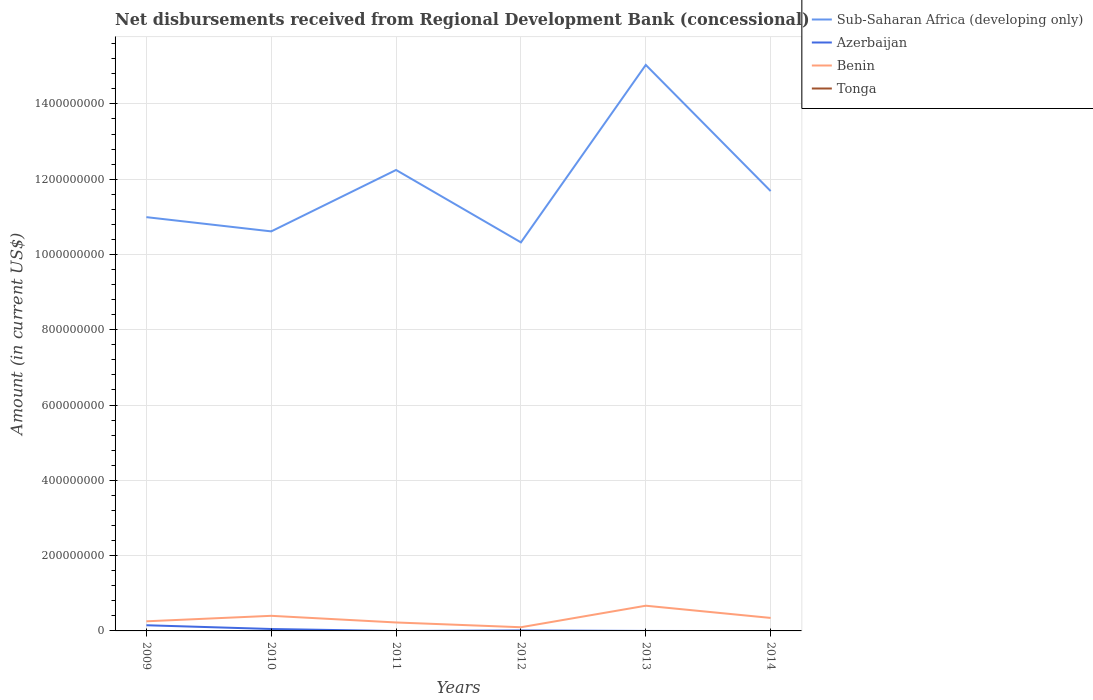Is the number of lines equal to the number of legend labels?
Ensure brevity in your answer.  No. Across all years, what is the maximum amount of disbursements received from Regional Development Bank in Benin?
Your response must be concise. 9.79e+06. What is the total amount of disbursements received from Regional Development Bank in Azerbaijan in the graph?
Keep it short and to the point. 9.99e+06. What is the difference between the highest and the second highest amount of disbursements received from Regional Development Bank in Azerbaijan?
Your response must be concise. 1.51e+07. What is the difference between the highest and the lowest amount of disbursements received from Regional Development Bank in Azerbaijan?
Ensure brevity in your answer.  2. Is the amount of disbursements received from Regional Development Bank in Benin strictly greater than the amount of disbursements received from Regional Development Bank in Tonga over the years?
Ensure brevity in your answer.  No. How many lines are there?
Your answer should be very brief. 3. Are the values on the major ticks of Y-axis written in scientific E-notation?
Give a very brief answer. No. Does the graph contain any zero values?
Your answer should be very brief. Yes. Does the graph contain grids?
Your answer should be compact. Yes. What is the title of the graph?
Offer a very short reply. Net disbursements received from Regional Development Bank (concessional). Does "Madagascar" appear as one of the legend labels in the graph?
Make the answer very short. No. What is the label or title of the X-axis?
Make the answer very short. Years. What is the Amount (in current US$) in Sub-Saharan Africa (developing only) in 2009?
Offer a terse response. 1.10e+09. What is the Amount (in current US$) in Azerbaijan in 2009?
Your response must be concise. 1.51e+07. What is the Amount (in current US$) of Benin in 2009?
Ensure brevity in your answer.  2.55e+07. What is the Amount (in current US$) in Sub-Saharan Africa (developing only) in 2010?
Your response must be concise. 1.06e+09. What is the Amount (in current US$) in Azerbaijan in 2010?
Provide a succinct answer. 5.08e+06. What is the Amount (in current US$) in Benin in 2010?
Your answer should be compact. 4.01e+07. What is the Amount (in current US$) of Sub-Saharan Africa (developing only) in 2011?
Your answer should be very brief. 1.22e+09. What is the Amount (in current US$) in Azerbaijan in 2011?
Offer a terse response. 0. What is the Amount (in current US$) of Benin in 2011?
Make the answer very short. 2.25e+07. What is the Amount (in current US$) of Tonga in 2011?
Provide a succinct answer. 0. What is the Amount (in current US$) in Sub-Saharan Africa (developing only) in 2012?
Keep it short and to the point. 1.03e+09. What is the Amount (in current US$) of Azerbaijan in 2012?
Your answer should be very brief. 1.30e+06. What is the Amount (in current US$) in Benin in 2012?
Ensure brevity in your answer.  9.79e+06. What is the Amount (in current US$) in Sub-Saharan Africa (developing only) in 2013?
Ensure brevity in your answer.  1.50e+09. What is the Amount (in current US$) of Azerbaijan in 2013?
Give a very brief answer. 0. What is the Amount (in current US$) of Benin in 2013?
Offer a very short reply. 6.69e+07. What is the Amount (in current US$) of Sub-Saharan Africa (developing only) in 2014?
Give a very brief answer. 1.17e+09. What is the Amount (in current US$) in Benin in 2014?
Ensure brevity in your answer.  3.45e+07. Across all years, what is the maximum Amount (in current US$) of Sub-Saharan Africa (developing only)?
Offer a terse response. 1.50e+09. Across all years, what is the maximum Amount (in current US$) of Azerbaijan?
Your answer should be very brief. 1.51e+07. Across all years, what is the maximum Amount (in current US$) in Benin?
Keep it short and to the point. 6.69e+07. Across all years, what is the minimum Amount (in current US$) in Sub-Saharan Africa (developing only)?
Provide a short and direct response. 1.03e+09. Across all years, what is the minimum Amount (in current US$) in Azerbaijan?
Your answer should be very brief. 0. Across all years, what is the minimum Amount (in current US$) in Benin?
Provide a succinct answer. 9.79e+06. What is the total Amount (in current US$) in Sub-Saharan Africa (developing only) in the graph?
Offer a terse response. 7.09e+09. What is the total Amount (in current US$) of Azerbaijan in the graph?
Provide a succinct answer. 2.15e+07. What is the total Amount (in current US$) in Benin in the graph?
Provide a succinct answer. 1.99e+08. What is the difference between the Amount (in current US$) in Sub-Saharan Africa (developing only) in 2009 and that in 2010?
Make the answer very short. 3.78e+07. What is the difference between the Amount (in current US$) of Azerbaijan in 2009 and that in 2010?
Offer a very short reply. 9.99e+06. What is the difference between the Amount (in current US$) of Benin in 2009 and that in 2010?
Offer a terse response. -1.46e+07. What is the difference between the Amount (in current US$) in Sub-Saharan Africa (developing only) in 2009 and that in 2011?
Provide a short and direct response. -1.25e+08. What is the difference between the Amount (in current US$) in Benin in 2009 and that in 2011?
Make the answer very short. 3.10e+06. What is the difference between the Amount (in current US$) in Sub-Saharan Africa (developing only) in 2009 and that in 2012?
Offer a very short reply. 6.70e+07. What is the difference between the Amount (in current US$) of Azerbaijan in 2009 and that in 2012?
Give a very brief answer. 1.38e+07. What is the difference between the Amount (in current US$) in Benin in 2009 and that in 2012?
Ensure brevity in your answer.  1.58e+07. What is the difference between the Amount (in current US$) of Sub-Saharan Africa (developing only) in 2009 and that in 2013?
Make the answer very short. -4.04e+08. What is the difference between the Amount (in current US$) in Benin in 2009 and that in 2013?
Provide a succinct answer. -4.14e+07. What is the difference between the Amount (in current US$) in Sub-Saharan Africa (developing only) in 2009 and that in 2014?
Offer a very short reply. -6.93e+07. What is the difference between the Amount (in current US$) in Benin in 2009 and that in 2014?
Offer a very short reply. -8.99e+06. What is the difference between the Amount (in current US$) in Sub-Saharan Africa (developing only) in 2010 and that in 2011?
Ensure brevity in your answer.  -1.63e+08. What is the difference between the Amount (in current US$) of Benin in 2010 and that in 2011?
Ensure brevity in your answer.  1.77e+07. What is the difference between the Amount (in current US$) in Sub-Saharan Africa (developing only) in 2010 and that in 2012?
Provide a short and direct response. 2.92e+07. What is the difference between the Amount (in current US$) in Azerbaijan in 2010 and that in 2012?
Your answer should be compact. 3.79e+06. What is the difference between the Amount (in current US$) of Benin in 2010 and that in 2012?
Provide a succinct answer. 3.03e+07. What is the difference between the Amount (in current US$) in Sub-Saharan Africa (developing only) in 2010 and that in 2013?
Ensure brevity in your answer.  -4.42e+08. What is the difference between the Amount (in current US$) of Benin in 2010 and that in 2013?
Give a very brief answer. -2.68e+07. What is the difference between the Amount (in current US$) of Sub-Saharan Africa (developing only) in 2010 and that in 2014?
Provide a short and direct response. -1.07e+08. What is the difference between the Amount (in current US$) of Benin in 2010 and that in 2014?
Your response must be concise. 5.58e+06. What is the difference between the Amount (in current US$) in Sub-Saharan Africa (developing only) in 2011 and that in 2012?
Provide a succinct answer. 1.92e+08. What is the difference between the Amount (in current US$) of Benin in 2011 and that in 2012?
Provide a short and direct response. 1.27e+07. What is the difference between the Amount (in current US$) of Sub-Saharan Africa (developing only) in 2011 and that in 2013?
Your response must be concise. -2.79e+08. What is the difference between the Amount (in current US$) of Benin in 2011 and that in 2013?
Ensure brevity in your answer.  -4.45e+07. What is the difference between the Amount (in current US$) in Sub-Saharan Africa (developing only) in 2011 and that in 2014?
Ensure brevity in your answer.  5.60e+07. What is the difference between the Amount (in current US$) in Benin in 2011 and that in 2014?
Offer a very short reply. -1.21e+07. What is the difference between the Amount (in current US$) of Sub-Saharan Africa (developing only) in 2012 and that in 2013?
Your answer should be compact. -4.71e+08. What is the difference between the Amount (in current US$) of Benin in 2012 and that in 2013?
Ensure brevity in your answer.  -5.72e+07. What is the difference between the Amount (in current US$) in Sub-Saharan Africa (developing only) in 2012 and that in 2014?
Offer a terse response. -1.36e+08. What is the difference between the Amount (in current US$) in Benin in 2012 and that in 2014?
Keep it short and to the point. -2.47e+07. What is the difference between the Amount (in current US$) in Sub-Saharan Africa (developing only) in 2013 and that in 2014?
Provide a short and direct response. 3.35e+08. What is the difference between the Amount (in current US$) in Benin in 2013 and that in 2014?
Your answer should be very brief. 3.24e+07. What is the difference between the Amount (in current US$) of Sub-Saharan Africa (developing only) in 2009 and the Amount (in current US$) of Azerbaijan in 2010?
Ensure brevity in your answer.  1.09e+09. What is the difference between the Amount (in current US$) of Sub-Saharan Africa (developing only) in 2009 and the Amount (in current US$) of Benin in 2010?
Keep it short and to the point. 1.06e+09. What is the difference between the Amount (in current US$) in Azerbaijan in 2009 and the Amount (in current US$) in Benin in 2010?
Your response must be concise. -2.50e+07. What is the difference between the Amount (in current US$) of Sub-Saharan Africa (developing only) in 2009 and the Amount (in current US$) of Benin in 2011?
Make the answer very short. 1.08e+09. What is the difference between the Amount (in current US$) of Azerbaijan in 2009 and the Amount (in current US$) of Benin in 2011?
Offer a very short reply. -7.38e+06. What is the difference between the Amount (in current US$) of Sub-Saharan Africa (developing only) in 2009 and the Amount (in current US$) of Azerbaijan in 2012?
Keep it short and to the point. 1.10e+09. What is the difference between the Amount (in current US$) in Sub-Saharan Africa (developing only) in 2009 and the Amount (in current US$) in Benin in 2012?
Your answer should be very brief. 1.09e+09. What is the difference between the Amount (in current US$) of Azerbaijan in 2009 and the Amount (in current US$) of Benin in 2012?
Provide a succinct answer. 5.28e+06. What is the difference between the Amount (in current US$) of Sub-Saharan Africa (developing only) in 2009 and the Amount (in current US$) of Benin in 2013?
Your response must be concise. 1.03e+09. What is the difference between the Amount (in current US$) of Azerbaijan in 2009 and the Amount (in current US$) of Benin in 2013?
Offer a terse response. -5.19e+07. What is the difference between the Amount (in current US$) of Sub-Saharan Africa (developing only) in 2009 and the Amount (in current US$) of Benin in 2014?
Keep it short and to the point. 1.06e+09. What is the difference between the Amount (in current US$) of Azerbaijan in 2009 and the Amount (in current US$) of Benin in 2014?
Keep it short and to the point. -1.95e+07. What is the difference between the Amount (in current US$) of Sub-Saharan Africa (developing only) in 2010 and the Amount (in current US$) of Benin in 2011?
Make the answer very short. 1.04e+09. What is the difference between the Amount (in current US$) of Azerbaijan in 2010 and the Amount (in current US$) of Benin in 2011?
Provide a short and direct response. -1.74e+07. What is the difference between the Amount (in current US$) in Sub-Saharan Africa (developing only) in 2010 and the Amount (in current US$) in Azerbaijan in 2012?
Your answer should be very brief. 1.06e+09. What is the difference between the Amount (in current US$) in Sub-Saharan Africa (developing only) in 2010 and the Amount (in current US$) in Benin in 2012?
Make the answer very short. 1.05e+09. What is the difference between the Amount (in current US$) of Azerbaijan in 2010 and the Amount (in current US$) of Benin in 2012?
Offer a very short reply. -4.71e+06. What is the difference between the Amount (in current US$) in Sub-Saharan Africa (developing only) in 2010 and the Amount (in current US$) in Benin in 2013?
Give a very brief answer. 9.94e+08. What is the difference between the Amount (in current US$) in Azerbaijan in 2010 and the Amount (in current US$) in Benin in 2013?
Provide a succinct answer. -6.19e+07. What is the difference between the Amount (in current US$) of Sub-Saharan Africa (developing only) in 2010 and the Amount (in current US$) of Benin in 2014?
Keep it short and to the point. 1.03e+09. What is the difference between the Amount (in current US$) of Azerbaijan in 2010 and the Amount (in current US$) of Benin in 2014?
Offer a very short reply. -2.95e+07. What is the difference between the Amount (in current US$) in Sub-Saharan Africa (developing only) in 2011 and the Amount (in current US$) in Azerbaijan in 2012?
Make the answer very short. 1.22e+09. What is the difference between the Amount (in current US$) of Sub-Saharan Africa (developing only) in 2011 and the Amount (in current US$) of Benin in 2012?
Make the answer very short. 1.21e+09. What is the difference between the Amount (in current US$) in Sub-Saharan Africa (developing only) in 2011 and the Amount (in current US$) in Benin in 2013?
Offer a very short reply. 1.16e+09. What is the difference between the Amount (in current US$) of Sub-Saharan Africa (developing only) in 2011 and the Amount (in current US$) of Benin in 2014?
Ensure brevity in your answer.  1.19e+09. What is the difference between the Amount (in current US$) of Sub-Saharan Africa (developing only) in 2012 and the Amount (in current US$) of Benin in 2013?
Ensure brevity in your answer.  9.65e+08. What is the difference between the Amount (in current US$) of Azerbaijan in 2012 and the Amount (in current US$) of Benin in 2013?
Offer a very short reply. -6.56e+07. What is the difference between the Amount (in current US$) of Sub-Saharan Africa (developing only) in 2012 and the Amount (in current US$) of Benin in 2014?
Keep it short and to the point. 9.98e+08. What is the difference between the Amount (in current US$) of Azerbaijan in 2012 and the Amount (in current US$) of Benin in 2014?
Your response must be concise. -3.32e+07. What is the difference between the Amount (in current US$) of Sub-Saharan Africa (developing only) in 2013 and the Amount (in current US$) of Benin in 2014?
Your answer should be very brief. 1.47e+09. What is the average Amount (in current US$) of Sub-Saharan Africa (developing only) per year?
Keep it short and to the point. 1.18e+09. What is the average Amount (in current US$) in Azerbaijan per year?
Keep it short and to the point. 3.58e+06. What is the average Amount (in current US$) in Benin per year?
Give a very brief answer. 3.32e+07. In the year 2009, what is the difference between the Amount (in current US$) of Sub-Saharan Africa (developing only) and Amount (in current US$) of Azerbaijan?
Your answer should be compact. 1.08e+09. In the year 2009, what is the difference between the Amount (in current US$) in Sub-Saharan Africa (developing only) and Amount (in current US$) in Benin?
Offer a terse response. 1.07e+09. In the year 2009, what is the difference between the Amount (in current US$) in Azerbaijan and Amount (in current US$) in Benin?
Keep it short and to the point. -1.05e+07. In the year 2010, what is the difference between the Amount (in current US$) in Sub-Saharan Africa (developing only) and Amount (in current US$) in Azerbaijan?
Your answer should be compact. 1.06e+09. In the year 2010, what is the difference between the Amount (in current US$) of Sub-Saharan Africa (developing only) and Amount (in current US$) of Benin?
Provide a succinct answer. 1.02e+09. In the year 2010, what is the difference between the Amount (in current US$) of Azerbaijan and Amount (in current US$) of Benin?
Make the answer very short. -3.50e+07. In the year 2011, what is the difference between the Amount (in current US$) in Sub-Saharan Africa (developing only) and Amount (in current US$) in Benin?
Your response must be concise. 1.20e+09. In the year 2012, what is the difference between the Amount (in current US$) of Sub-Saharan Africa (developing only) and Amount (in current US$) of Azerbaijan?
Your answer should be compact. 1.03e+09. In the year 2012, what is the difference between the Amount (in current US$) in Sub-Saharan Africa (developing only) and Amount (in current US$) in Benin?
Your answer should be very brief. 1.02e+09. In the year 2012, what is the difference between the Amount (in current US$) of Azerbaijan and Amount (in current US$) of Benin?
Provide a succinct answer. -8.49e+06. In the year 2013, what is the difference between the Amount (in current US$) of Sub-Saharan Africa (developing only) and Amount (in current US$) of Benin?
Provide a succinct answer. 1.44e+09. In the year 2014, what is the difference between the Amount (in current US$) in Sub-Saharan Africa (developing only) and Amount (in current US$) in Benin?
Your response must be concise. 1.13e+09. What is the ratio of the Amount (in current US$) of Sub-Saharan Africa (developing only) in 2009 to that in 2010?
Offer a very short reply. 1.04. What is the ratio of the Amount (in current US$) of Azerbaijan in 2009 to that in 2010?
Offer a terse response. 2.96. What is the ratio of the Amount (in current US$) of Benin in 2009 to that in 2010?
Your answer should be compact. 0.64. What is the ratio of the Amount (in current US$) in Sub-Saharan Africa (developing only) in 2009 to that in 2011?
Provide a succinct answer. 0.9. What is the ratio of the Amount (in current US$) in Benin in 2009 to that in 2011?
Your response must be concise. 1.14. What is the ratio of the Amount (in current US$) in Sub-Saharan Africa (developing only) in 2009 to that in 2012?
Your response must be concise. 1.06. What is the ratio of the Amount (in current US$) in Azerbaijan in 2009 to that in 2012?
Give a very brief answer. 11.62. What is the ratio of the Amount (in current US$) of Benin in 2009 to that in 2012?
Keep it short and to the point. 2.61. What is the ratio of the Amount (in current US$) in Sub-Saharan Africa (developing only) in 2009 to that in 2013?
Give a very brief answer. 0.73. What is the ratio of the Amount (in current US$) of Benin in 2009 to that in 2013?
Give a very brief answer. 0.38. What is the ratio of the Amount (in current US$) of Sub-Saharan Africa (developing only) in 2009 to that in 2014?
Provide a succinct answer. 0.94. What is the ratio of the Amount (in current US$) in Benin in 2009 to that in 2014?
Give a very brief answer. 0.74. What is the ratio of the Amount (in current US$) of Sub-Saharan Africa (developing only) in 2010 to that in 2011?
Keep it short and to the point. 0.87. What is the ratio of the Amount (in current US$) of Benin in 2010 to that in 2011?
Ensure brevity in your answer.  1.79. What is the ratio of the Amount (in current US$) in Sub-Saharan Africa (developing only) in 2010 to that in 2012?
Your answer should be very brief. 1.03. What is the ratio of the Amount (in current US$) of Azerbaijan in 2010 to that in 2012?
Ensure brevity in your answer.  3.92. What is the ratio of the Amount (in current US$) of Benin in 2010 to that in 2012?
Your answer should be very brief. 4.1. What is the ratio of the Amount (in current US$) of Sub-Saharan Africa (developing only) in 2010 to that in 2013?
Give a very brief answer. 0.71. What is the ratio of the Amount (in current US$) of Benin in 2010 to that in 2013?
Provide a short and direct response. 0.6. What is the ratio of the Amount (in current US$) of Sub-Saharan Africa (developing only) in 2010 to that in 2014?
Your answer should be compact. 0.91. What is the ratio of the Amount (in current US$) in Benin in 2010 to that in 2014?
Keep it short and to the point. 1.16. What is the ratio of the Amount (in current US$) in Sub-Saharan Africa (developing only) in 2011 to that in 2012?
Make the answer very short. 1.19. What is the ratio of the Amount (in current US$) in Benin in 2011 to that in 2012?
Ensure brevity in your answer.  2.29. What is the ratio of the Amount (in current US$) in Sub-Saharan Africa (developing only) in 2011 to that in 2013?
Your response must be concise. 0.81. What is the ratio of the Amount (in current US$) of Benin in 2011 to that in 2013?
Your response must be concise. 0.34. What is the ratio of the Amount (in current US$) in Sub-Saharan Africa (developing only) in 2011 to that in 2014?
Offer a terse response. 1.05. What is the ratio of the Amount (in current US$) of Benin in 2011 to that in 2014?
Provide a succinct answer. 0.65. What is the ratio of the Amount (in current US$) in Sub-Saharan Africa (developing only) in 2012 to that in 2013?
Ensure brevity in your answer.  0.69. What is the ratio of the Amount (in current US$) in Benin in 2012 to that in 2013?
Offer a terse response. 0.15. What is the ratio of the Amount (in current US$) in Sub-Saharan Africa (developing only) in 2012 to that in 2014?
Provide a succinct answer. 0.88. What is the ratio of the Amount (in current US$) of Benin in 2012 to that in 2014?
Give a very brief answer. 0.28. What is the ratio of the Amount (in current US$) of Sub-Saharan Africa (developing only) in 2013 to that in 2014?
Offer a terse response. 1.29. What is the ratio of the Amount (in current US$) in Benin in 2013 to that in 2014?
Give a very brief answer. 1.94. What is the difference between the highest and the second highest Amount (in current US$) of Sub-Saharan Africa (developing only)?
Ensure brevity in your answer.  2.79e+08. What is the difference between the highest and the second highest Amount (in current US$) in Azerbaijan?
Give a very brief answer. 9.99e+06. What is the difference between the highest and the second highest Amount (in current US$) in Benin?
Provide a short and direct response. 2.68e+07. What is the difference between the highest and the lowest Amount (in current US$) of Sub-Saharan Africa (developing only)?
Your answer should be compact. 4.71e+08. What is the difference between the highest and the lowest Amount (in current US$) of Azerbaijan?
Keep it short and to the point. 1.51e+07. What is the difference between the highest and the lowest Amount (in current US$) of Benin?
Make the answer very short. 5.72e+07. 